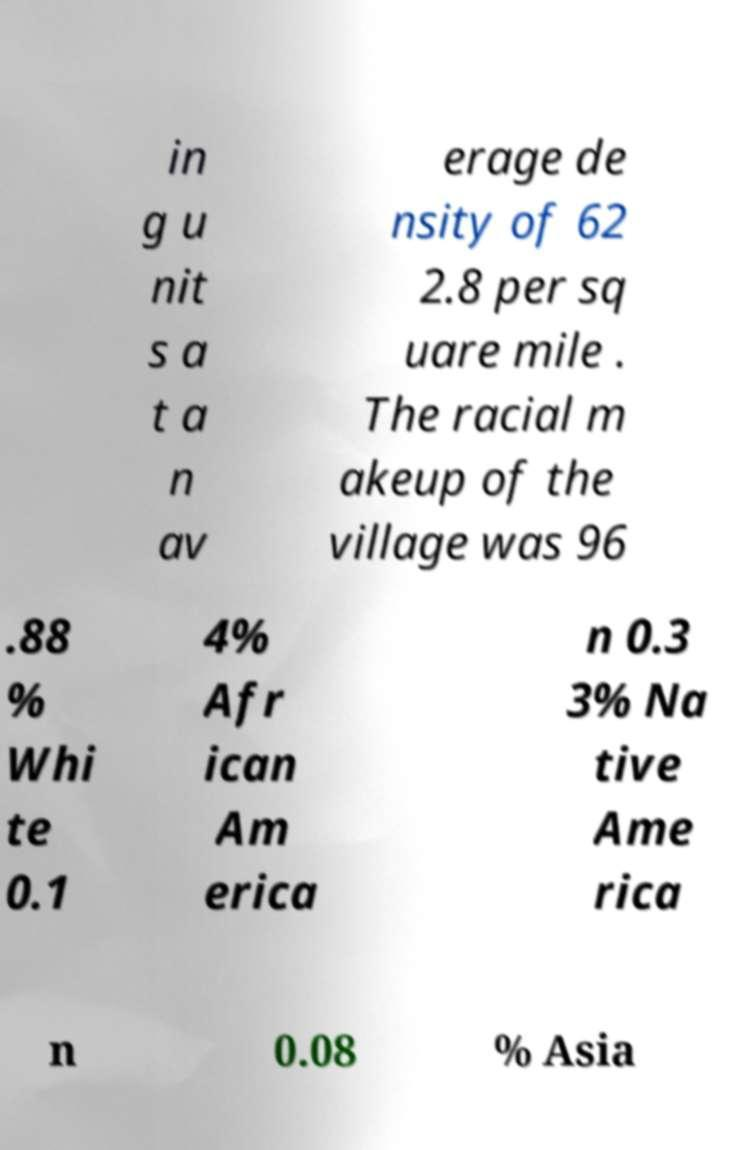Could you extract and type out the text from this image? in g u nit s a t a n av erage de nsity of 62 2.8 per sq uare mile . The racial m akeup of the village was 96 .88 % Whi te 0.1 4% Afr ican Am erica n 0.3 3% Na tive Ame rica n 0.08 % Asia 